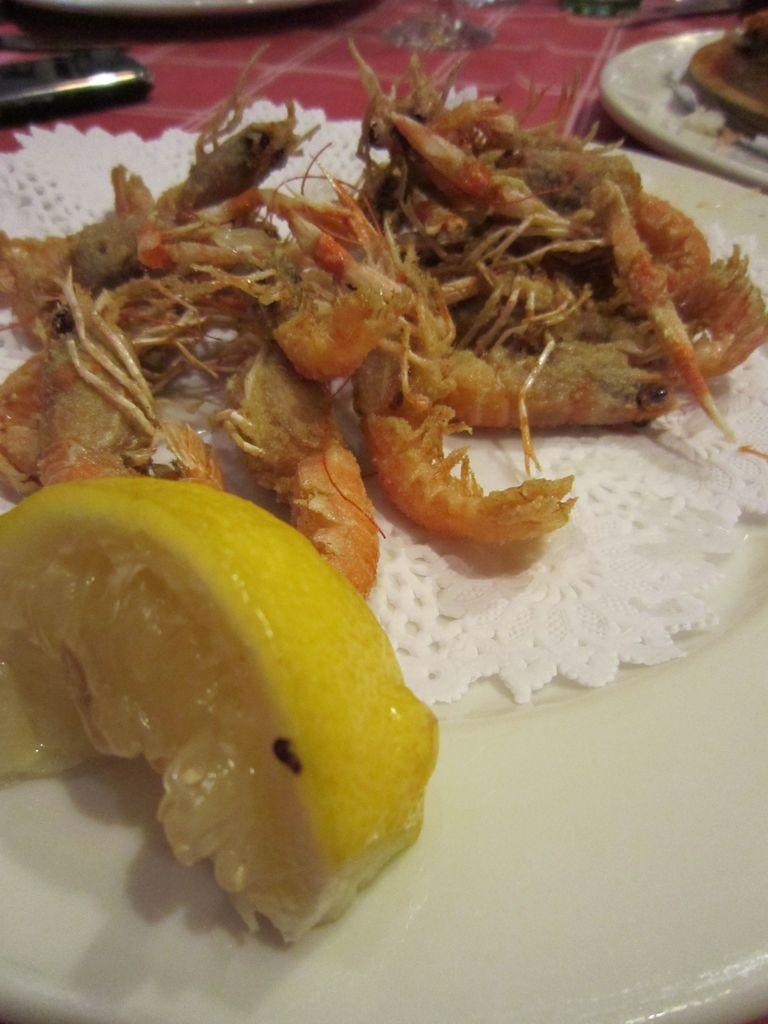What is on the plate that is visible in the image? There is a plate with eatable items in the image. Are there any other plates in the image? Yes, there is another plate in the image. What is the color of the cloth on which the plates are placed? The plates are placed on a red cloth. What rule is being enforced in the image? There is no indication of a rule being enforced in the image. What is the location of the image, specifically downtown? The location of the image is not specified, and there is no information about it being downtown. 